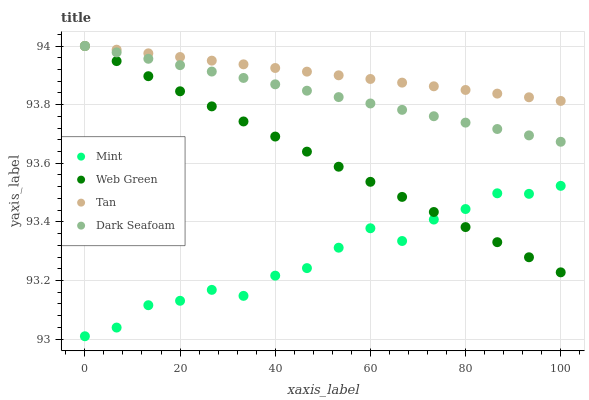Does Mint have the minimum area under the curve?
Answer yes or no. Yes. Does Tan have the maximum area under the curve?
Answer yes or no. Yes. Does Dark Seafoam have the minimum area under the curve?
Answer yes or no. No. Does Dark Seafoam have the maximum area under the curve?
Answer yes or no. No. Is Web Green the smoothest?
Answer yes or no. Yes. Is Mint the roughest?
Answer yes or no. Yes. Is Dark Seafoam the smoothest?
Answer yes or no. No. Is Dark Seafoam the roughest?
Answer yes or no. No. Does Mint have the lowest value?
Answer yes or no. Yes. Does Dark Seafoam have the lowest value?
Answer yes or no. No. Does Web Green have the highest value?
Answer yes or no. Yes. Does Mint have the highest value?
Answer yes or no. No. Is Mint less than Tan?
Answer yes or no. Yes. Is Tan greater than Mint?
Answer yes or no. Yes. Does Dark Seafoam intersect Tan?
Answer yes or no. Yes. Is Dark Seafoam less than Tan?
Answer yes or no. No. Is Dark Seafoam greater than Tan?
Answer yes or no. No. Does Mint intersect Tan?
Answer yes or no. No. 